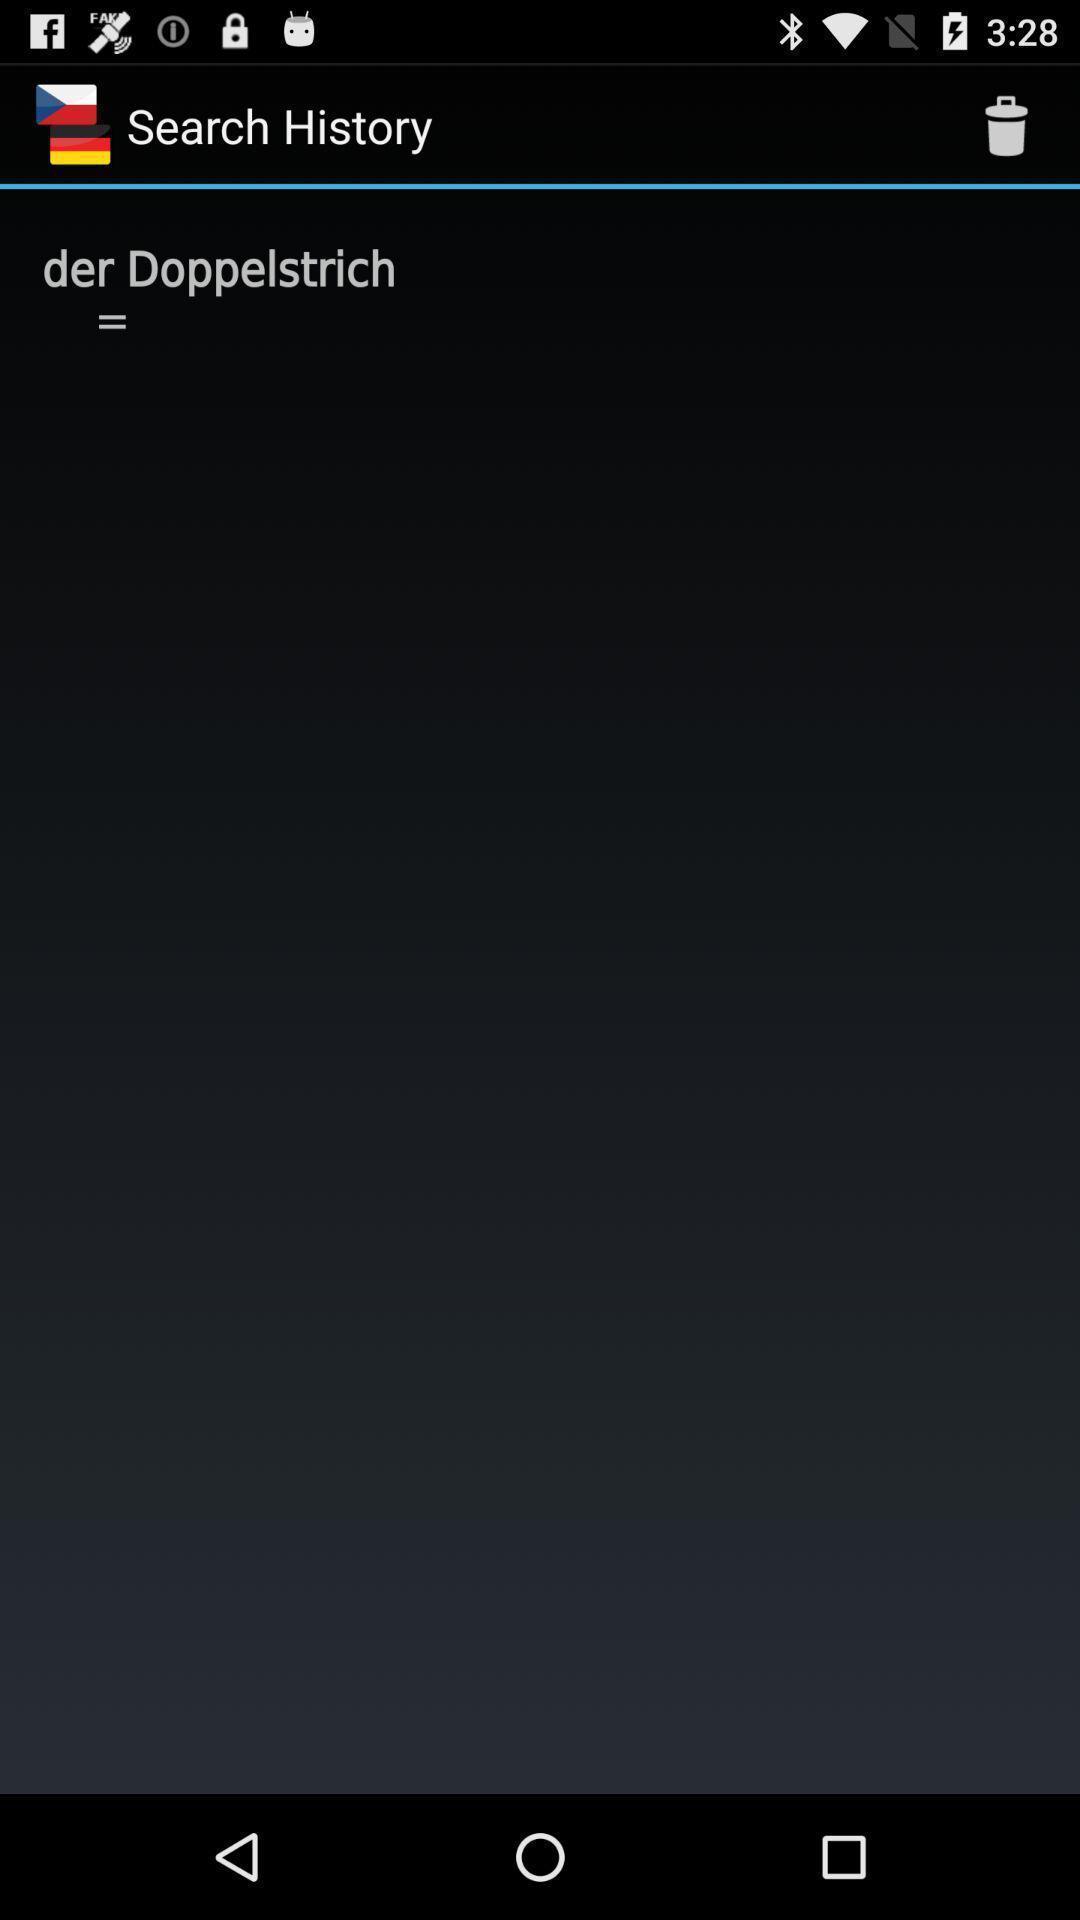Describe the content in this image. Screen showing search history. 